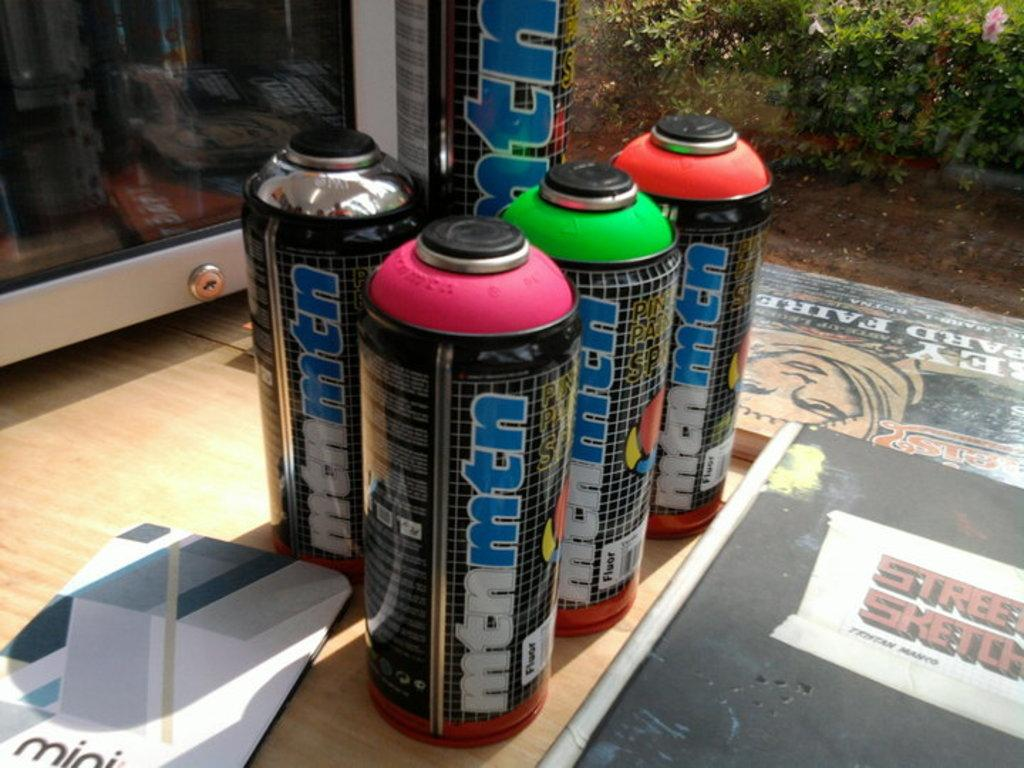Provide a one-sentence caption for the provided image. A few cans of different colors called mtnmtn. 